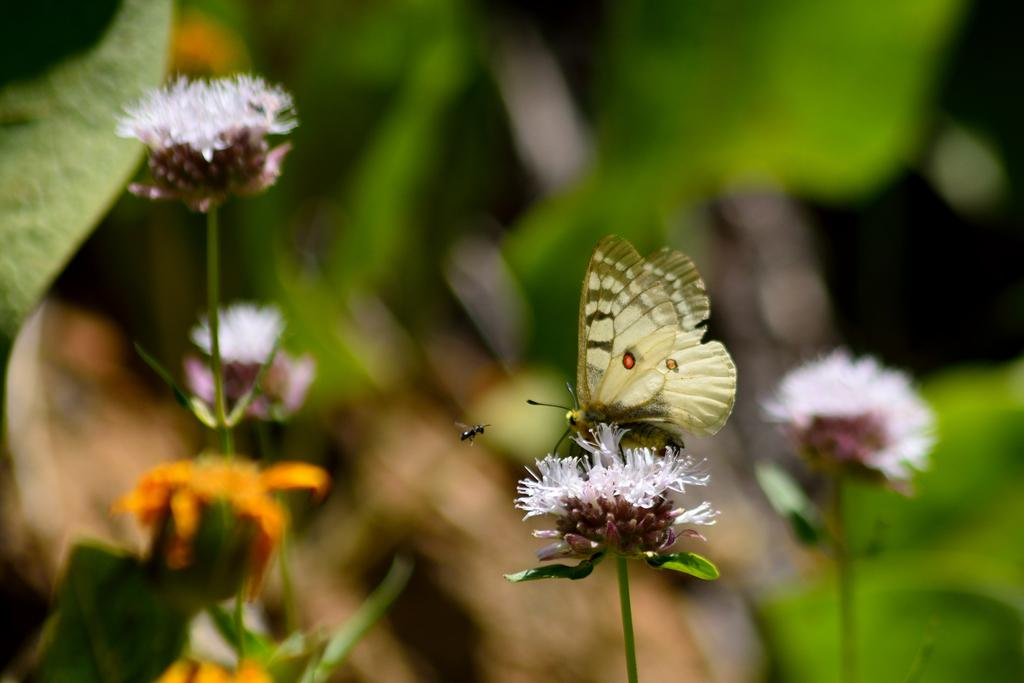What is the main subject of the image? There is a butterfly on a flower in the image. What else can be seen in the image besides the butterfly? An insect is flying in the air in the image, and there are flowers and leaves on the left side of the image. Where is another flower located in the image? There is a flower at the right bottom of the image. How would you describe the background of the image? The background of the image is blurry. What type of lunchroom can be seen in the image? There is no lunchroom present in the image; it features a butterfly on a flower and other natural elements. What kind of lumber is visible in the image? There is no lumber present in the image; it is a nature scene with a butterfly, flowers, and leaves. 